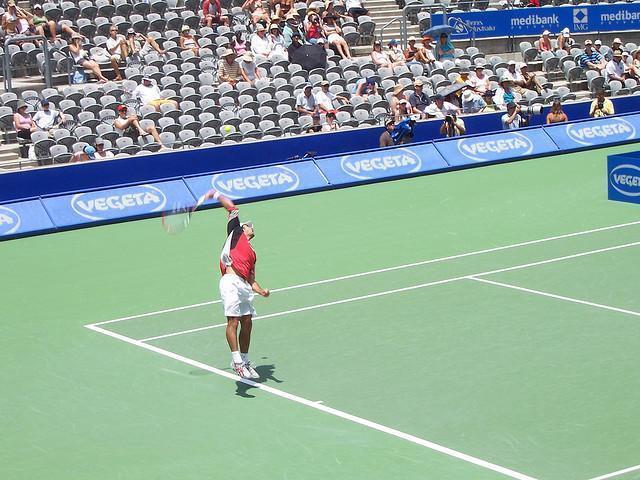How many people are there?
Give a very brief answer. 2. How many laptops are on the table?
Give a very brief answer. 0. 